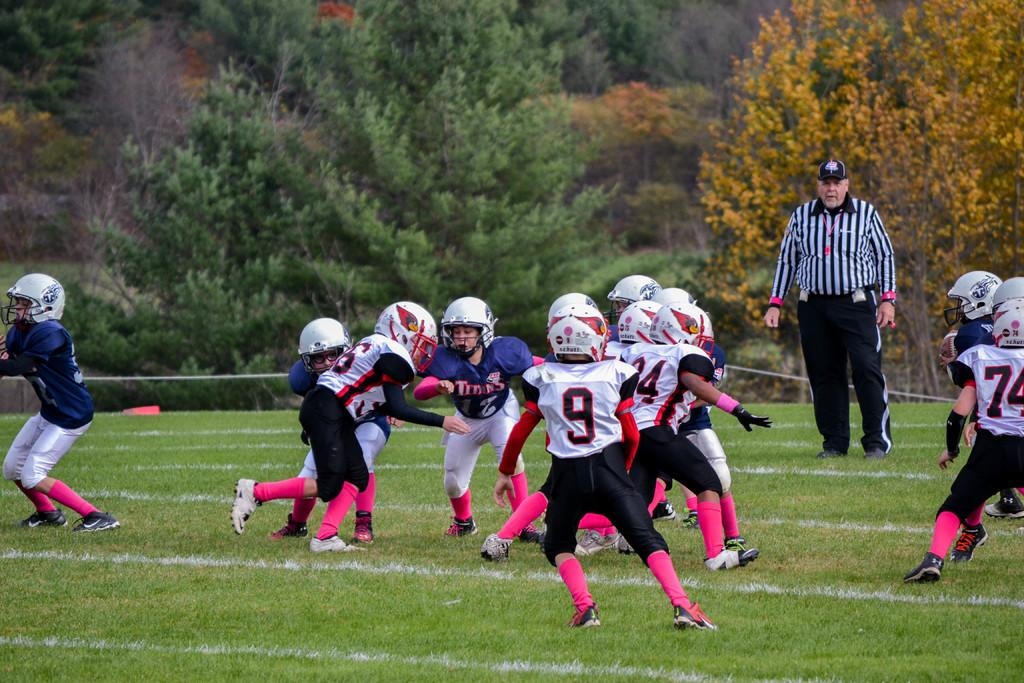What are the people in the image doing? The people in the image are playing on the ground. Can you describe the person in charge of the game in the image? There is a referee in the background of the image. What can be seen in the distance behind the people playing? There are trees in the background of the image. How many bears are visible in the image? There are no bears present in the image. What type of heart-related activity is taking place in the image? There is no heart-related activity depicted in the image. 